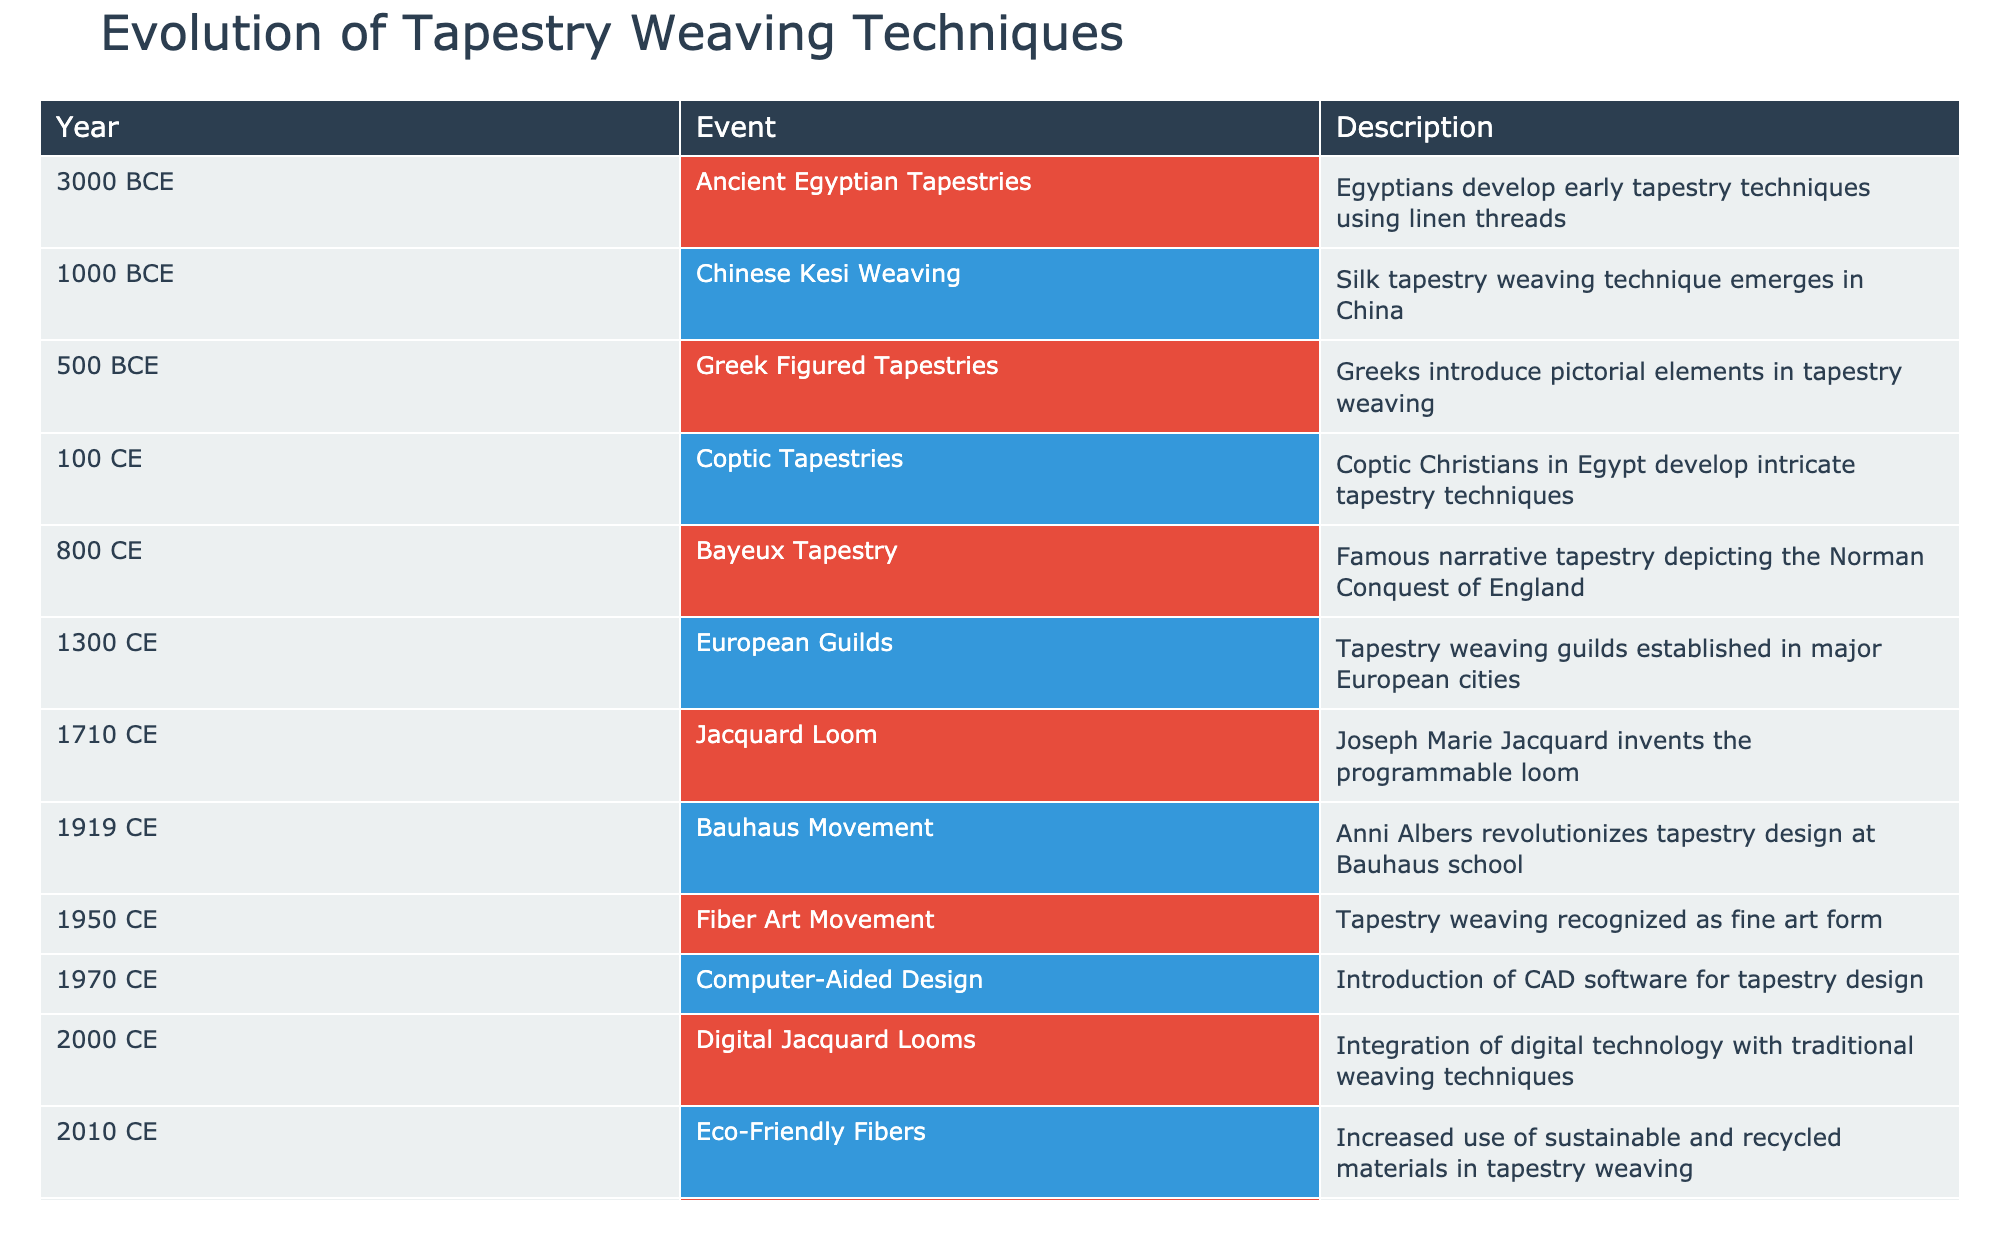What year did the Coptic Tapestries emerge? According to the table, Coptic Tapestries were developed in 100 CE. Therefore, the answer is 100 CE.
Answer: 100 CE Which technique is attributed to the Chinese Kesi Weaving? The table states that Kesi Weaving is a silk tapestry technique that emerged in China around 1000 BCE.
Answer: Silk tapestry weaving What major development occurred in 1710 CE? The table mentions that in 1710 CE, Joseph Marie Jacquard invented the programmable loom, marking a significant development in tapestry weaving techniques.
Answer: The programmable loom was invented What is the difference in years between the introduction of Eco-Friendly Fibers and the Coptic Tapestries? The year for Coptic Tapestries is 100 CE and for Eco-Friendly Fibers is 2010 CE. The difference is 2010 - 100 = 1910 years.
Answer: 1910 years Is the Bauhaus Movement related to tapestry weaving? Yes, the table indicates that the Bauhaus Movement in 1919 CE, led by Anni Albers, revolutionized tapestry design, confirming its relevance to tapestry weaving.
Answer: Yes How many significant events in tapestry weaving occurred between 800 CE and 1300 CE? By referencing the table, the events during this period include the Bayeux Tapestry in 800 CE and the establishment of European Guilds in 1300 CE, which totals 2 significant events.
Answer: 2 events Which event marked the recognition of tapestry weaving as a fine art form? The table specifies that in 1950 CE, the Fiber Art Movement recognized tapestry weaving as a fine art form, making it the marked event.
Answer: The Fiber Art Movement in 1950 CE What is the trend regarding materials used in tapestry weaving from 2010 onwards? The table states that in 2010 CE, there was an increased use of sustainable and recycled materials, suggesting a trend towards eco-friendliness in the materials used for tapestry weaving.
Answer: An increased use of sustainable materials What year marks the introduction of computer-aided design in tapestry weaving? According to the table, Computer-Aided Design was introduced in 1970 CE, thus marking the year of this development.
Answer: 1970 CE 